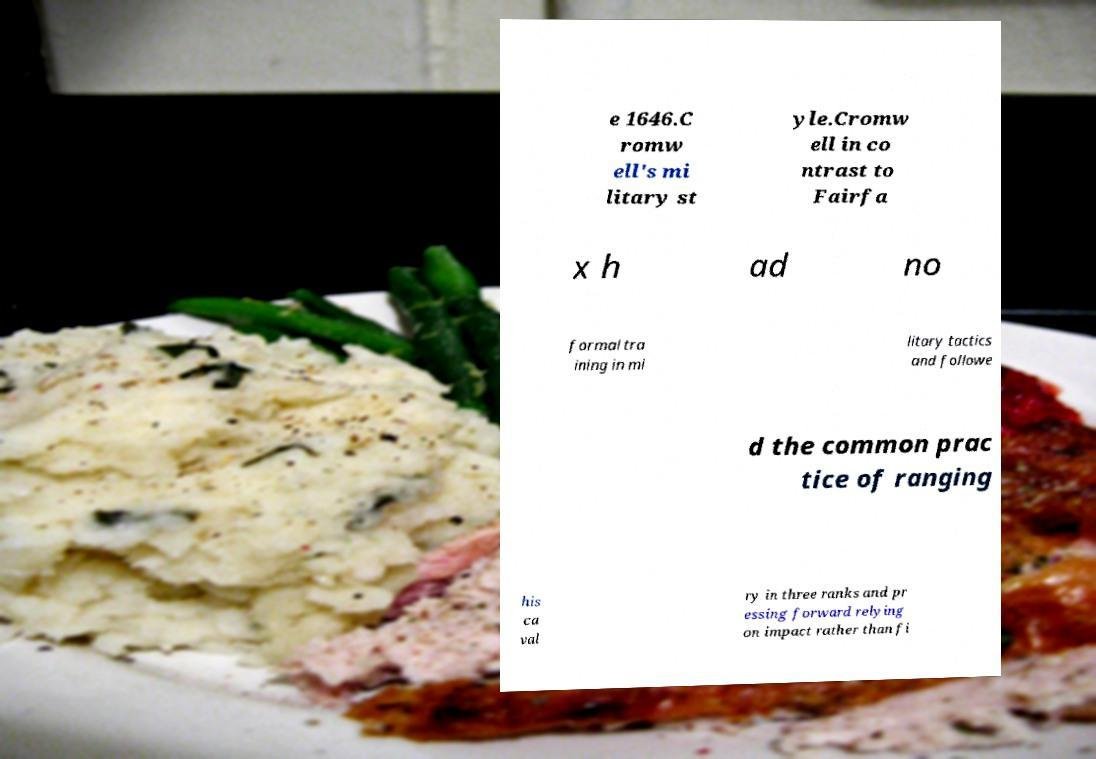For documentation purposes, I need the text within this image transcribed. Could you provide that? e 1646.C romw ell's mi litary st yle.Cromw ell in co ntrast to Fairfa x h ad no formal tra ining in mi litary tactics and followe d the common prac tice of ranging his ca val ry in three ranks and pr essing forward relying on impact rather than fi 